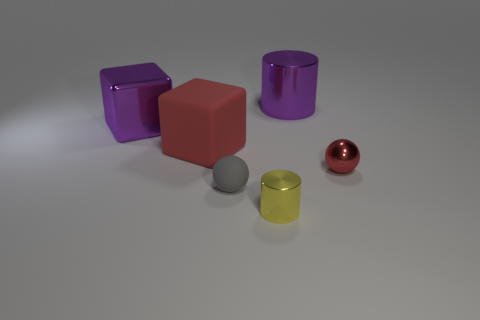Subtract all blocks. How many objects are left? 4 Add 1 yellow metal objects. How many yellow metal objects exist? 2 Add 2 small matte things. How many objects exist? 8 Subtract 0 gray cylinders. How many objects are left? 6 Subtract all brown cylinders. Subtract all cyan blocks. How many cylinders are left? 2 Subtract all yellow spheres. How many purple cubes are left? 1 Subtract all big rubber cubes. Subtract all large purple metallic things. How many objects are left? 3 Add 4 tiny red objects. How many tiny red objects are left? 5 